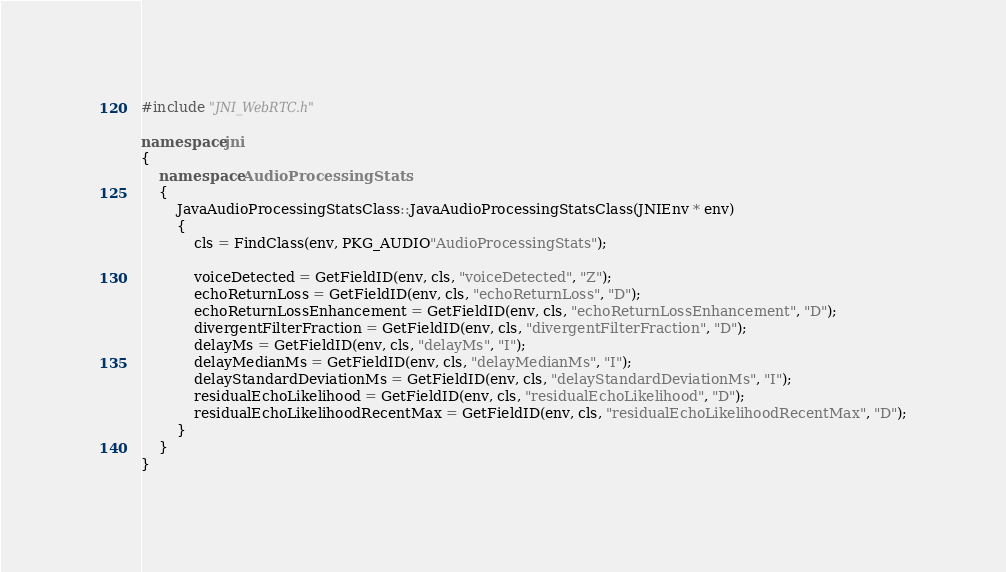Convert code to text. <code><loc_0><loc_0><loc_500><loc_500><_C++_>#include "JNI_WebRTC.h"

namespace jni
{
	namespace AudioProcessingStats
	{
		JavaAudioProcessingStatsClass::JavaAudioProcessingStatsClass(JNIEnv * env)
		{
			cls = FindClass(env, PKG_AUDIO"AudioProcessingStats");

			voiceDetected = GetFieldID(env, cls, "voiceDetected", "Z");
			echoReturnLoss = GetFieldID(env, cls, "echoReturnLoss", "D");
			echoReturnLossEnhancement = GetFieldID(env, cls, "echoReturnLossEnhancement", "D");
			divergentFilterFraction = GetFieldID(env, cls, "divergentFilterFraction", "D");
			delayMs = GetFieldID(env, cls, "delayMs", "I");
			delayMedianMs = GetFieldID(env, cls, "delayMedianMs", "I");
			delayStandardDeviationMs = GetFieldID(env, cls, "delayStandardDeviationMs", "I");
			residualEchoLikelihood = GetFieldID(env, cls, "residualEchoLikelihood", "D");
			residualEchoLikelihoodRecentMax = GetFieldID(env, cls, "residualEchoLikelihoodRecentMax", "D");
		}
	}
}</code> 